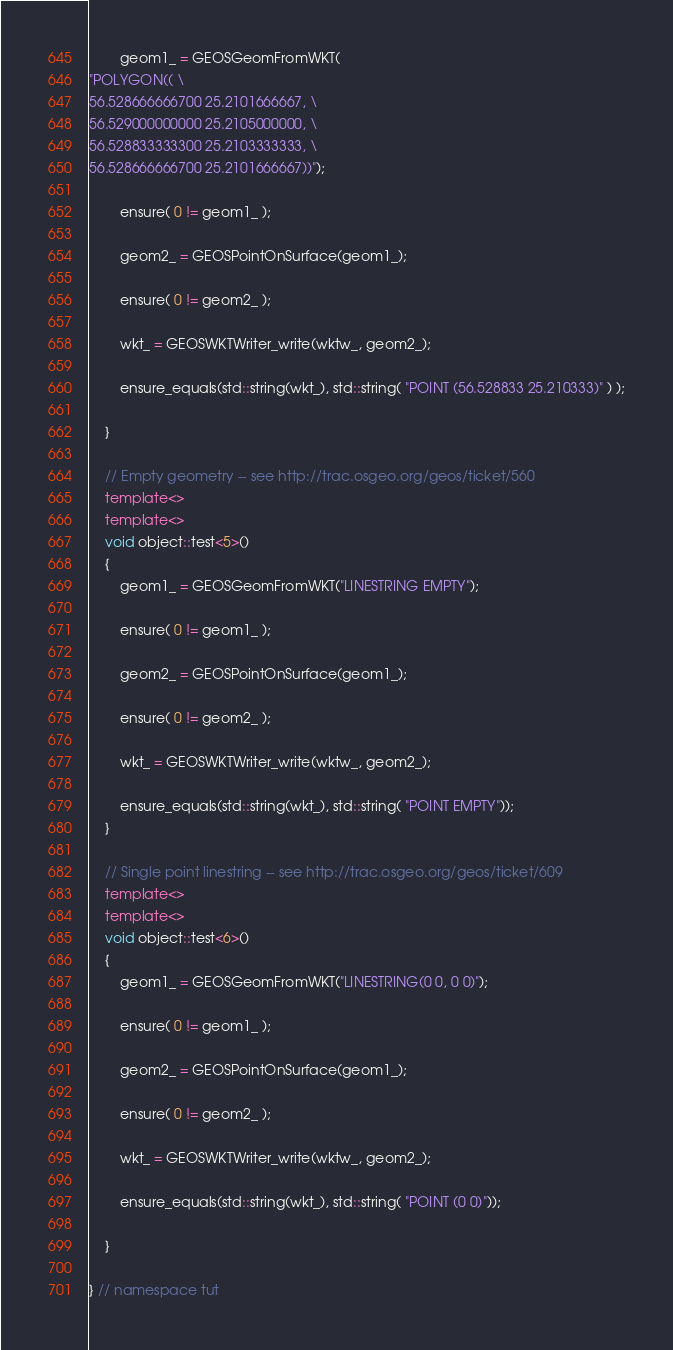<code> <loc_0><loc_0><loc_500><loc_500><_C++_>        geom1_ = GEOSGeomFromWKT(
"POLYGON(( \
56.528666666700 25.2101666667, \
56.529000000000 25.2105000000, \
56.528833333300 25.2103333333, \
56.528666666700 25.2101666667))");

        ensure( 0 != geom1_ );

        geom2_ = GEOSPointOnSurface(geom1_);

        ensure( 0 != geom2_ );

        wkt_ = GEOSWKTWriter_write(wktw_, geom2_);

        ensure_equals(std::string(wkt_), std::string( "POINT (56.528833 25.210333)" ) );

    }

    // Empty geometry -- see http://trac.osgeo.org/geos/ticket/560
    template<>
    template<>
    void object::test<5>()
    {
        geom1_ = GEOSGeomFromWKT("LINESTRING EMPTY");

        ensure( 0 != geom1_ );

        geom2_ = GEOSPointOnSurface(geom1_);

        ensure( 0 != geom2_ );

        wkt_ = GEOSWKTWriter_write(wktw_, geom2_);

        ensure_equals(std::string(wkt_), std::string( "POINT EMPTY"));
    }

    // Single point linestring -- see http://trac.osgeo.org/geos/ticket/609
    template<>
    template<>
    void object::test<6>()
    {
        geom1_ = GEOSGeomFromWKT("LINESTRING(0 0, 0 0)");

        ensure( 0 != geom1_ );

        geom2_ = GEOSPointOnSurface(geom1_);

        ensure( 0 != geom2_ );

        wkt_ = GEOSWKTWriter_write(wktw_, geom2_);

        ensure_equals(std::string(wkt_), std::string( "POINT (0 0)"));

    }

} // namespace tut

</code> 